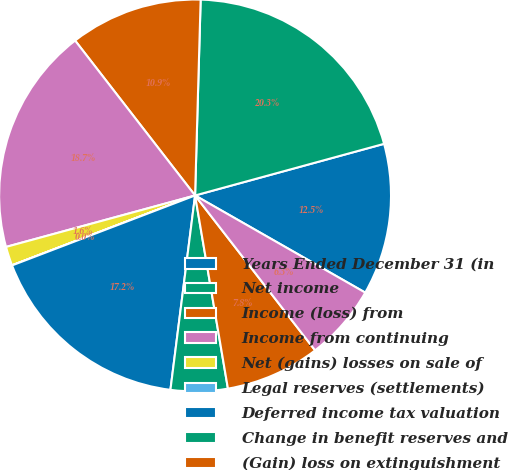Convert chart to OTSL. <chart><loc_0><loc_0><loc_500><loc_500><pie_chart><fcel>Years Ended December 31 (in<fcel>Net income<fcel>Income (loss) from<fcel>Income from continuing<fcel>Net (gains) losses on sale of<fcel>Legal reserves (settlements)<fcel>Deferred income tax valuation<fcel>Change in benefit reserves and<fcel>(Gain) loss on extinguishment<fcel>Net realized capital (gains)<nl><fcel>12.5%<fcel>20.3%<fcel>10.94%<fcel>18.74%<fcel>1.57%<fcel>0.01%<fcel>17.18%<fcel>4.69%<fcel>7.81%<fcel>6.25%<nl></chart> 